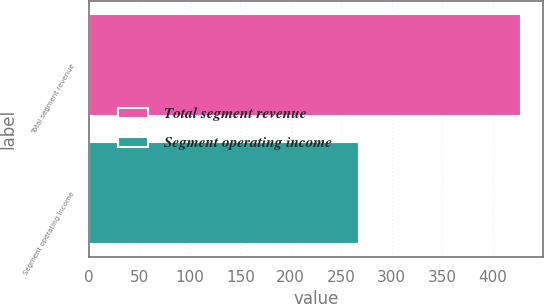Convert chart to OTSL. <chart><loc_0><loc_0><loc_500><loc_500><bar_chart><fcel>Total segment revenue<fcel>Segment operating income<nl><fcel>428<fcel>268<nl></chart> 